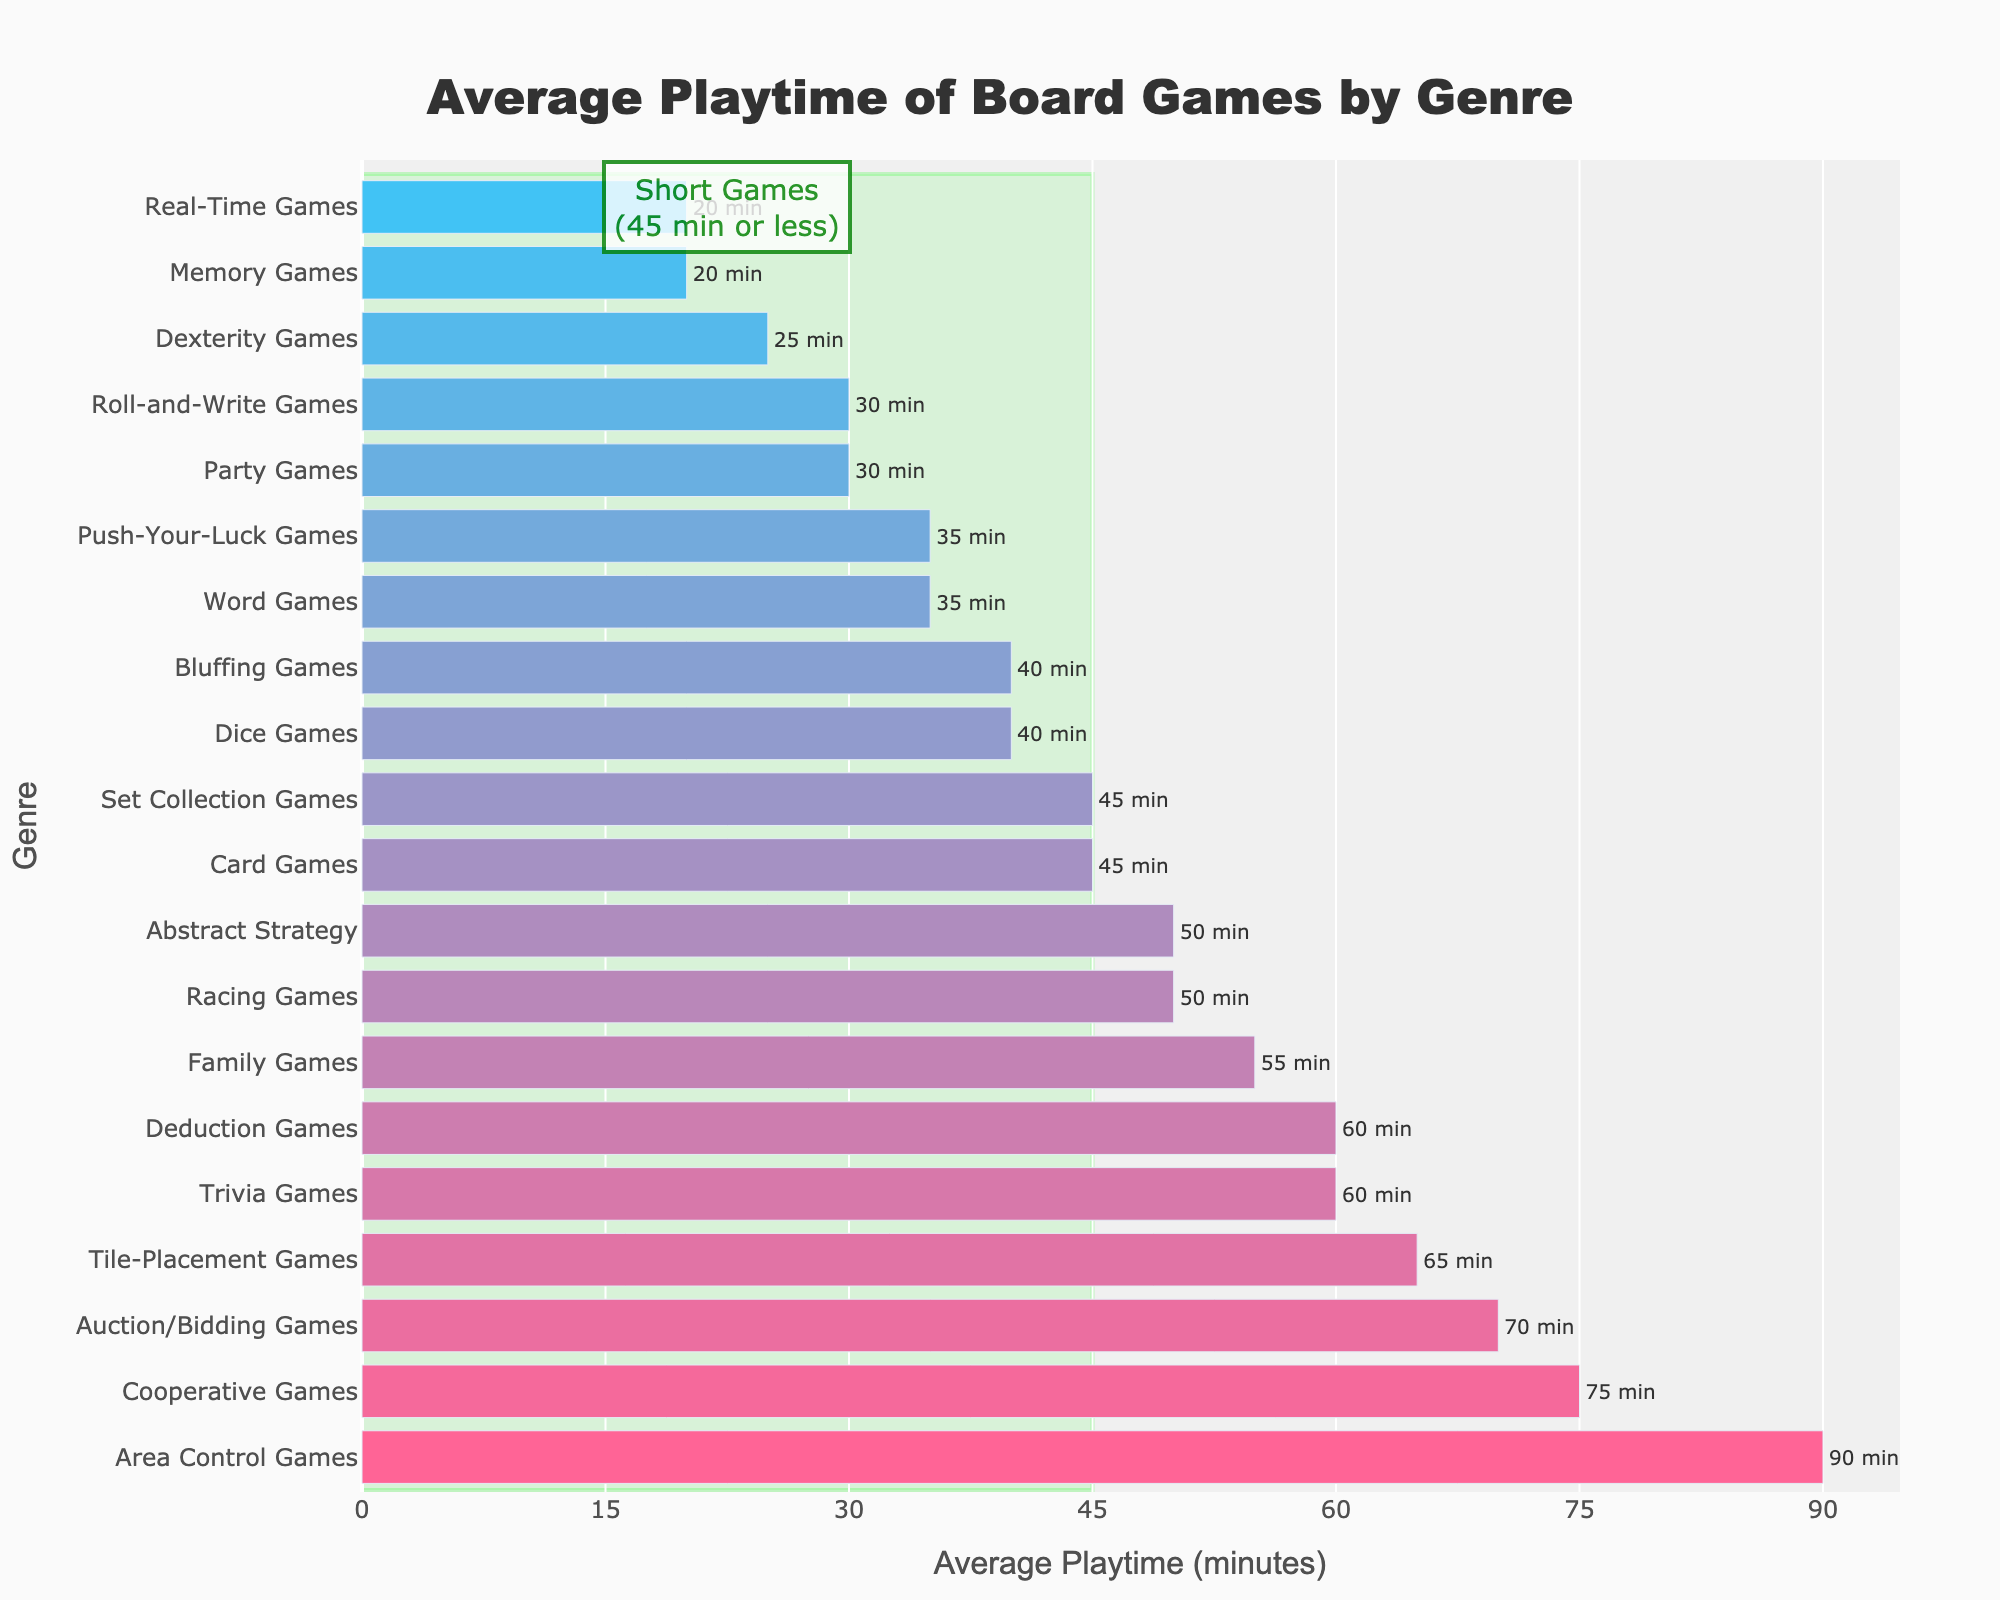Which genre has the shortest average playtime? By looking at the bar chart, the shortest bar represents the genre with the least average playtime. Dexterity Games have the shortest average playtime of 25 minutes.
Answer: Dexterity Games Which genre has the longest average playtime? By looking at the bar chart, the longest bar represents the genre with the greatest average playtime. Area Control Games have the longest average playtime of 90 minutes.
Answer: Area Control Games What is the difference in average playtime between Trivia Games and Memory Games? Trivia Games have an average playtime of 60 minutes, and Memory Games have an average playtime of 20 minutes. The difference is calculated as 60 - 20 = 40 minutes.
Answer: 40 minutes Which genres fall within the "Short Games" category (45 minutes or less)? The rectangle highlights the genres with average playtimes of 45 minutes or less. These genres are Party Games, Card Games, Dice Games, Dexterity Games, Word Games, Roll-and-Write Games, Bluffing Games, Push-Your-Luck Games, Memory Games, and Real-Time Games.
Answer: Party Games, Card Games, Dice Games, Dexterity Games, Word Games, Roll-and-Write Games, Bluffing Games, Push-Your-Luck Games, Memory Games, Real-Time Games How many genres have an average playtime greater than 60 minutes? By examining the bars with average playtimes longer than 60 minutes, there are four such genres: Cooperative Games, Tile-Placement Games, Auction/Bidding Games, and Area Control Games.
Answer: 4 How does the average playtime of Family Games compare to Deduction Games? Family Games have an average playtime of 55 minutes, and Deduction Games have an average playtime of 60 minutes. Therefore, Deduction Games have a greater playtime than Family Games by 5 minutes.
Answer: Deduction Games have 5 more minutes Which genre closest to 45 minutes average playtime but falls into the "Short Games" category? Card Games and Set Collection Games both have an average playtime of 45 minutes. Since Card Games fall under the "Short Games" category, it is the correct answer.
Answer: Card Games What is the average playtime of Bluffing Games and Set Collection Games combined? Bluffing Games have an average playtime of 40 minutes, and Set Collection Games have an average playtime of 45 minutes. The combined average is (40 + 45) / 2 = 42.5 minutes.
Answer: 42.5 minutes What is the difference between the genres with the highest and lowest playtimes? Area Control Games have the highest average playtime of 90 minutes, and Memory Games have the lowest average playtime of 20 minutes. The difference is calculated as 90 - 20 = 70 minutes.
Answer: 70 minutes 